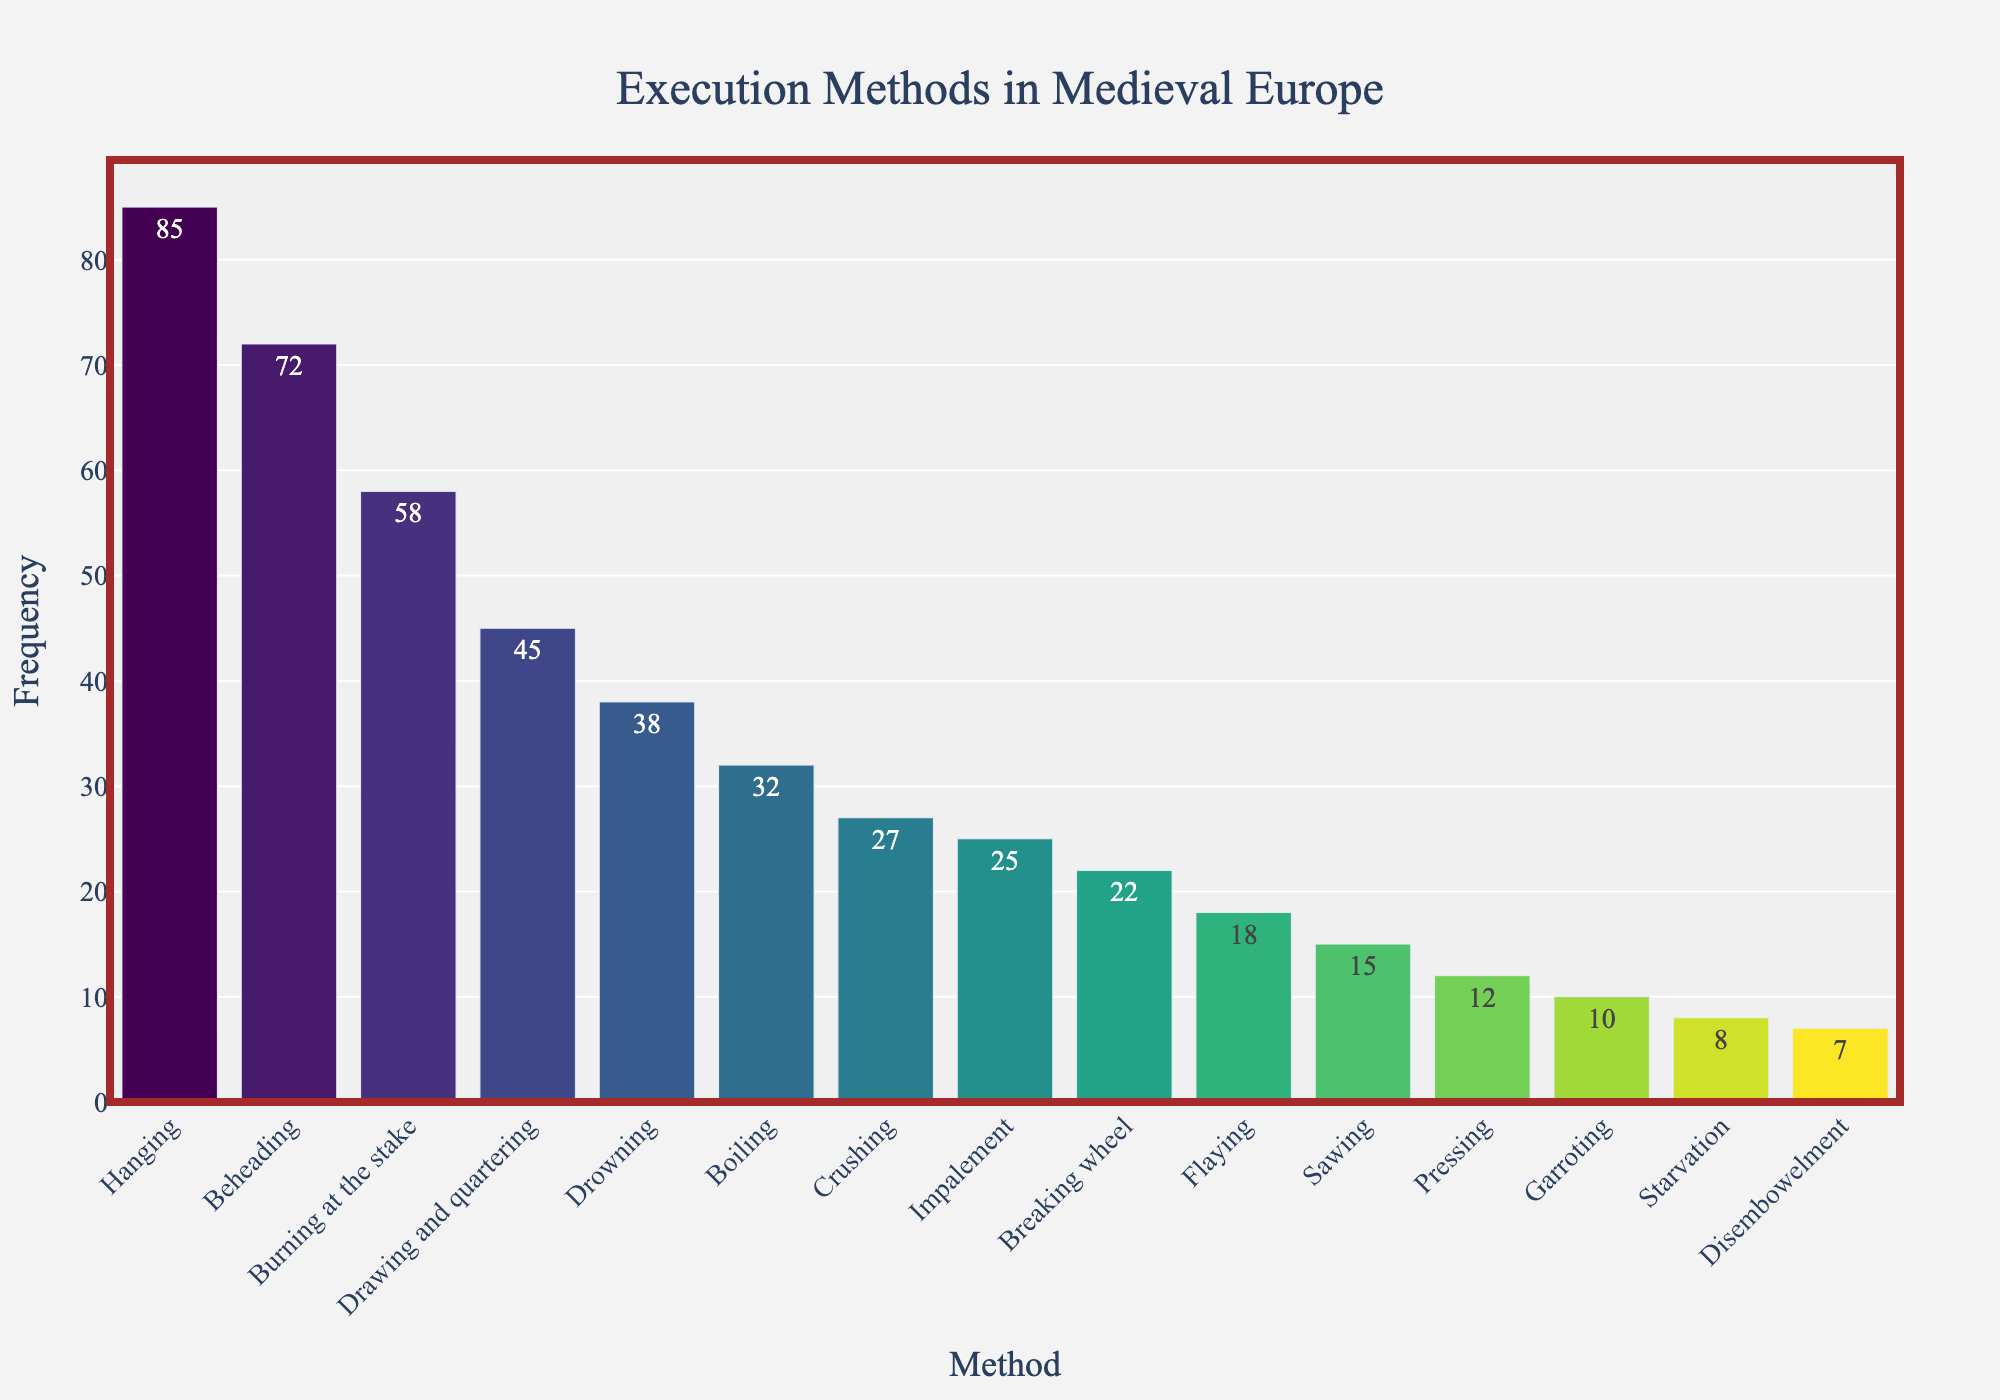What is the most common execution method in Medieval Europe? The bar chart shows the frequency of different execution methods. The bar with the highest value represents the most common method. "Hanging" has the highest frequency of 85.
Answer: Hanging How many more times was beheading used compared to disembowelment? To find the difference, locate the frequency of both beheading (72) and disembowelment (7). Subtract the frequency of disembowelment from beheading: 72 - 7 = 65.
Answer: 65 Which execution method was used less frequently: crushing or starvation? Compare the heights of the bars labeled "Crushing" and "Starvation." Crushing has a frequency of 27, while starvation has a frequency of 8. Crushing is more frequent than starvation.
Answer: Starvation Sum the frequencies of the top three most common execution methods. Identify the top three methods: Hanging (85), Beheading (72), and Burning at the stake (58). Add their frequencies together: 85 + 72 + 58 = 215.
Answer: 215 Calculate the average frequency of execution methods with a frequency greater than 50. Identify the methods with frequencies greater than 50: Hanging (85), Beheading (72), and Burning at the stake (58). Sum their frequencies and divide by the number of methods: (85 + 72 + 58) / 3 = 215 / 3 ≈ 71.67.
Answer: 71.67 Which method is represented by the shortest bar in the chart? The shortest bar corresponds to the method with the lowest frequency. "Disembowelment" has a frequency of 7, which is the smallest among all methods.
Answer: Disembowelment Are there more methods with a frequency above or below 30? Count the number of methods with a frequency above 30: Hanging, Beheading, Burning at the stake, Drawing and quartering, Drowning, and Boiling (6 methods). Count methods below 30: Crushing, Impalement, Breaking wheel, Flaying, Sawing, Pressing, Garroting, Starvation, and Disembowelment (9 methods). There are more methods with frequencies below 30.
Answer: Below 30 What is the difference in frequency between the highest and lowest methods depicted in the chart? Identify the highest frequency (Hanging: 85) and the lowest frequency (Disembowelment: 7). Subtract the lowest from the highest: 85 - 7 = 78.
Answer: 78 